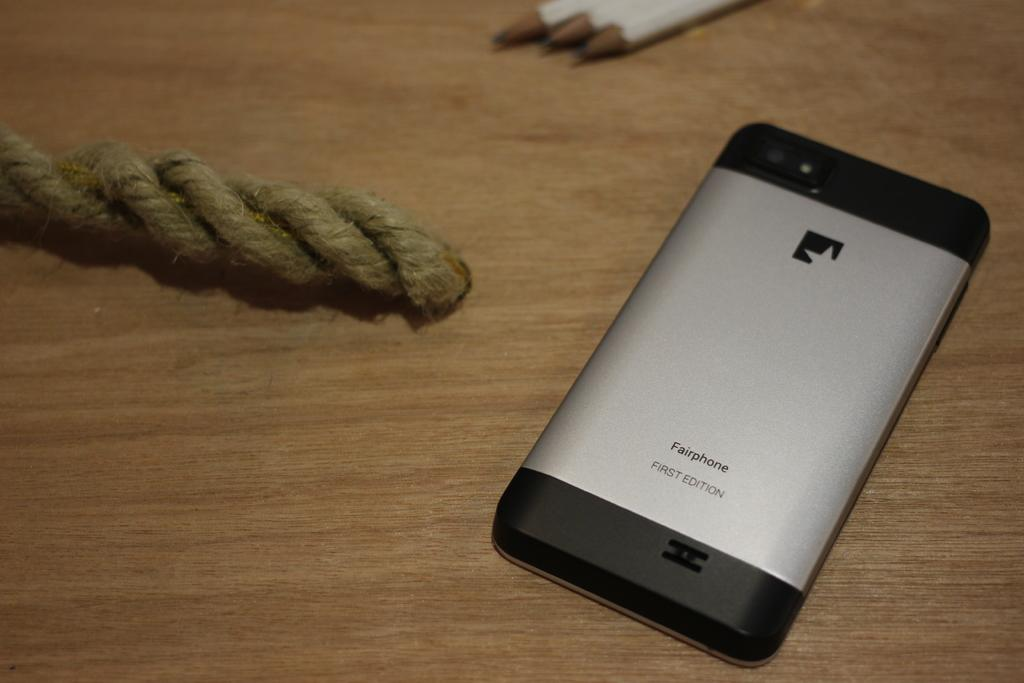<image>
Render a clear and concise summary of the photo. A black and silver Fairphone on a wooden table. 